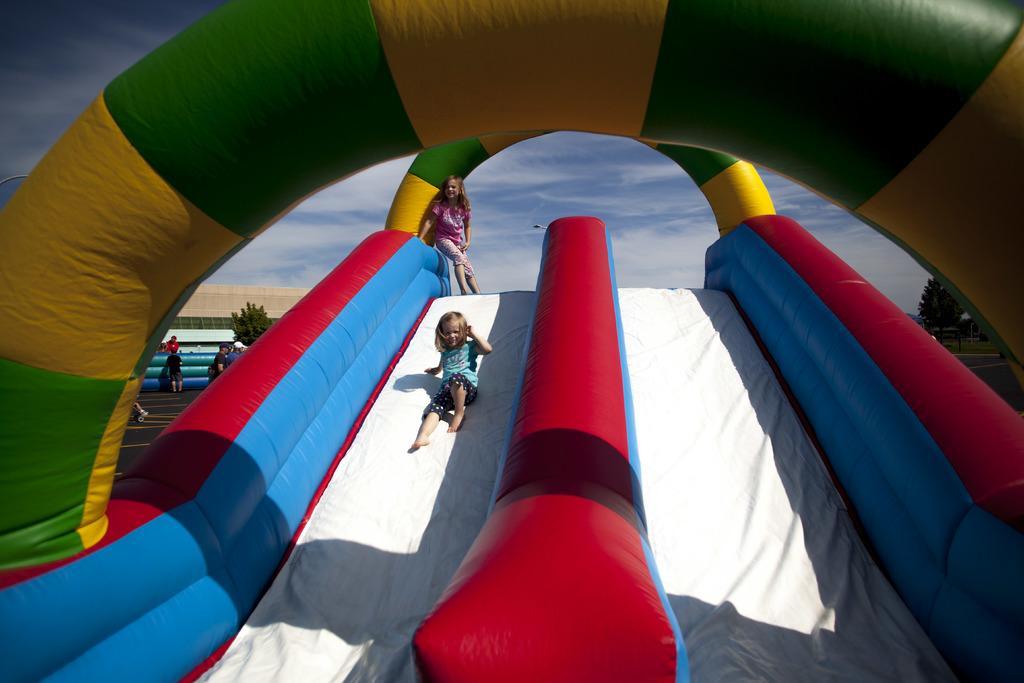How would you summarize this image in a sentence or two? In this picture we can see the inflatable balloon slides and two small girls are sliding. On the top we can see the sky. 